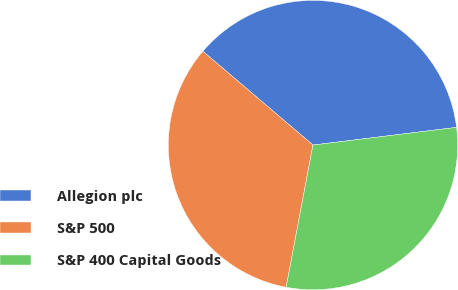Convert chart. <chart><loc_0><loc_0><loc_500><loc_500><pie_chart><fcel>Allegion plc<fcel>S&P 500<fcel>S&P 400 Capital Goods<nl><fcel>36.82%<fcel>33.26%<fcel>29.92%<nl></chart> 